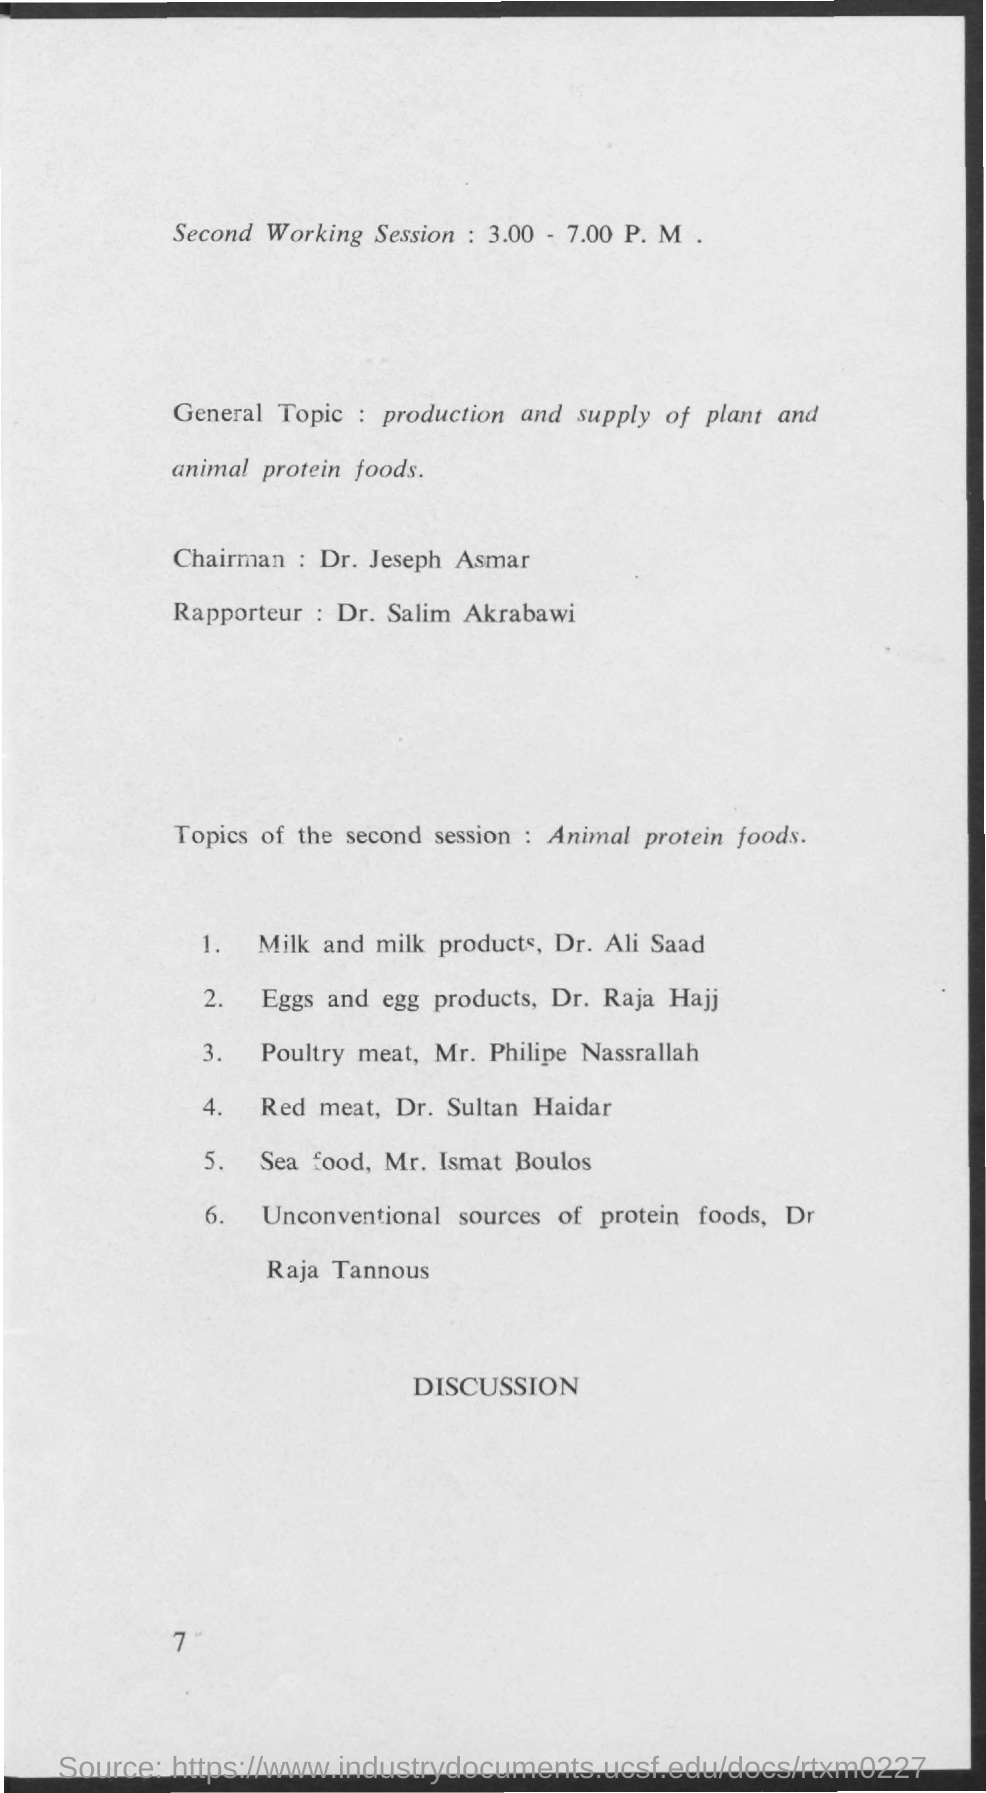What is the designation of Jeseph Asmar?
Offer a terse response. Chairman. 